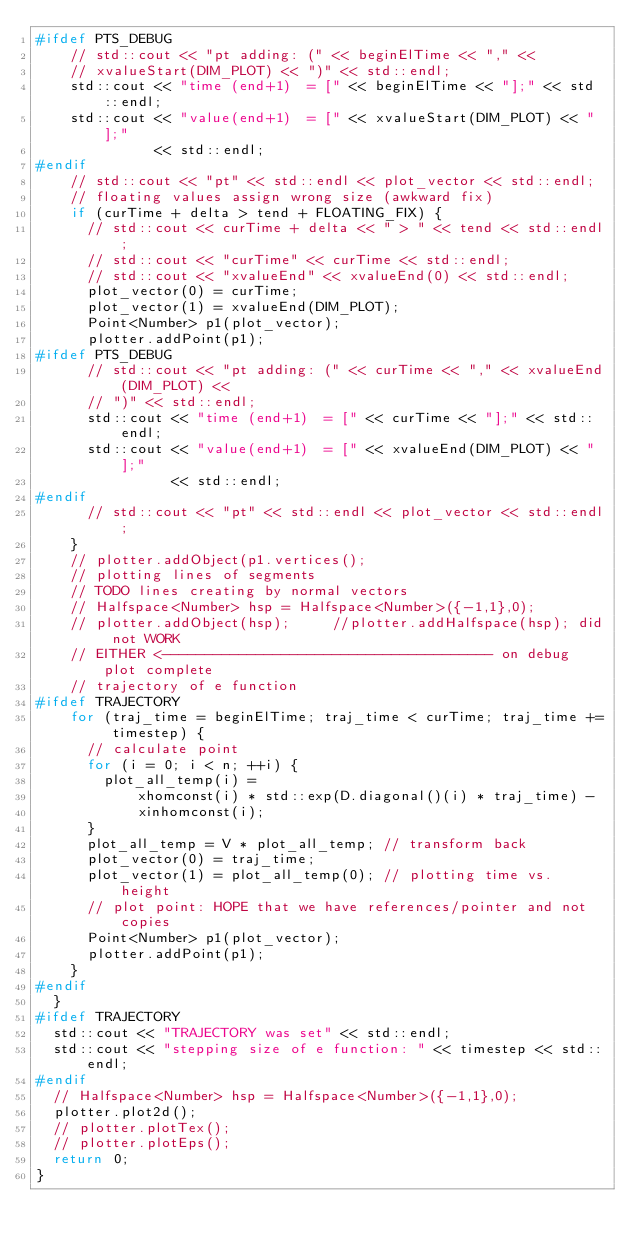Convert code to text. <code><loc_0><loc_0><loc_500><loc_500><_C++_>#ifdef PTS_DEBUG
    // std::cout << "pt adding: (" << beginElTime << "," <<
    // xvalueStart(DIM_PLOT) << ")" << std::endl;
    std::cout << "time (end+1)  = [" << beginElTime << "];" << std::endl;
    std::cout << "value(end+1)  = [" << xvalueStart(DIM_PLOT) << "];"
              << std::endl;
#endif
    // std::cout << "pt" << std::endl << plot_vector << std::endl;
    // floating values assign wrong size (awkward fix)
    if (curTime + delta > tend + FLOATING_FIX) {
      // std::cout << curTime + delta << " > " << tend << std::endl;
      // std::cout << "curTime" << curTime << std::endl;
      // std::cout << "xvalueEnd" << xvalueEnd(0) << std::endl;
      plot_vector(0) = curTime;
      plot_vector(1) = xvalueEnd(DIM_PLOT);
      Point<Number> p1(plot_vector);
      plotter.addPoint(p1);
#ifdef PTS_DEBUG
      // std::cout << "pt adding: (" << curTime << "," << xvalueEnd(DIM_PLOT) <<
      // ")" << std::endl;
      std::cout << "time (end+1)  = [" << curTime << "];" << std::endl;
      std::cout << "value(end+1)  = [" << xvalueEnd(DIM_PLOT) << "];"
                << std::endl;
#endif
      // std::cout << "pt" << std::endl << plot_vector << std::endl;
    }
    // plotter.addObject(p1.vertices();
    // plotting lines of segments
    // TODO lines creating by normal vectors
    // Halfspace<Number> hsp = Halfspace<Number>({-1,1},0);
    // plotter.addObject(hsp);     //plotter.addHalfspace(hsp); did not WORK
    // EITHER <--------------------------------------- on debug plot complete
    // trajectory of e function
#ifdef TRAJECTORY
    for (traj_time = beginElTime; traj_time < curTime; traj_time += timestep) {
      // calculate point
      for (i = 0; i < n; ++i) {
        plot_all_temp(i) =
            xhomconst(i) * std::exp(D.diagonal()(i) * traj_time) -
            xinhomconst(i);
      }
      plot_all_temp = V * plot_all_temp; // transform back
      plot_vector(0) = traj_time;
      plot_vector(1) = plot_all_temp(0); // plotting time vs. height
      // plot point: HOPE that we have references/pointer and not copies
      Point<Number> p1(plot_vector);
      plotter.addPoint(p1);
    }
#endif
  }
#ifdef TRAJECTORY
  std::cout << "TRAJECTORY was set" << std::endl;
  std::cout << "stepping size of e function: " << timestep << std::endl;
#endif
  // Halfspace<Number> hsp = Halfspace<Number>({-1,1},0);
  plotter.plot2d();
  // plotter.plotTex();
  // plotter.plotEps();
  return 0;
}
</code> 